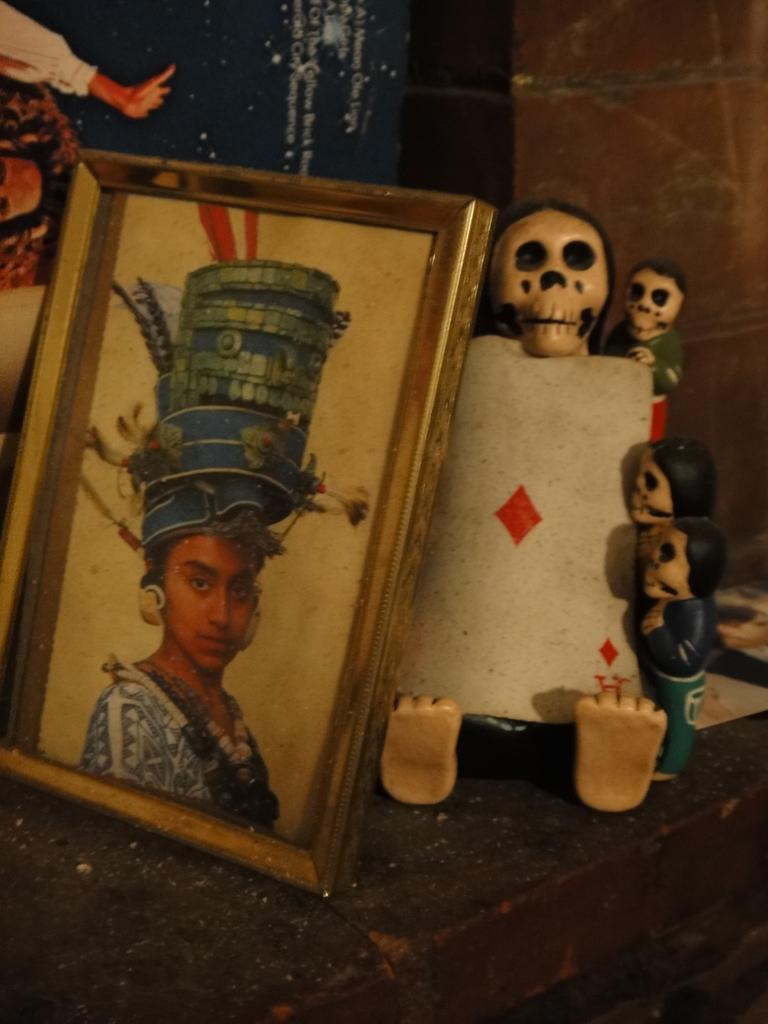What objects are visible in the image that are used for displaying photos? There are photo frames in the image. What other items can be seen in the image? There are toys in the image. Where are the photo frames and toys located? The photo frames and toys are placed on a surface. How many square frogs are sitting on the turkey in the image? There are no frogs or turkeys present in the image; it only features photo frames and toys placed on a surface. 